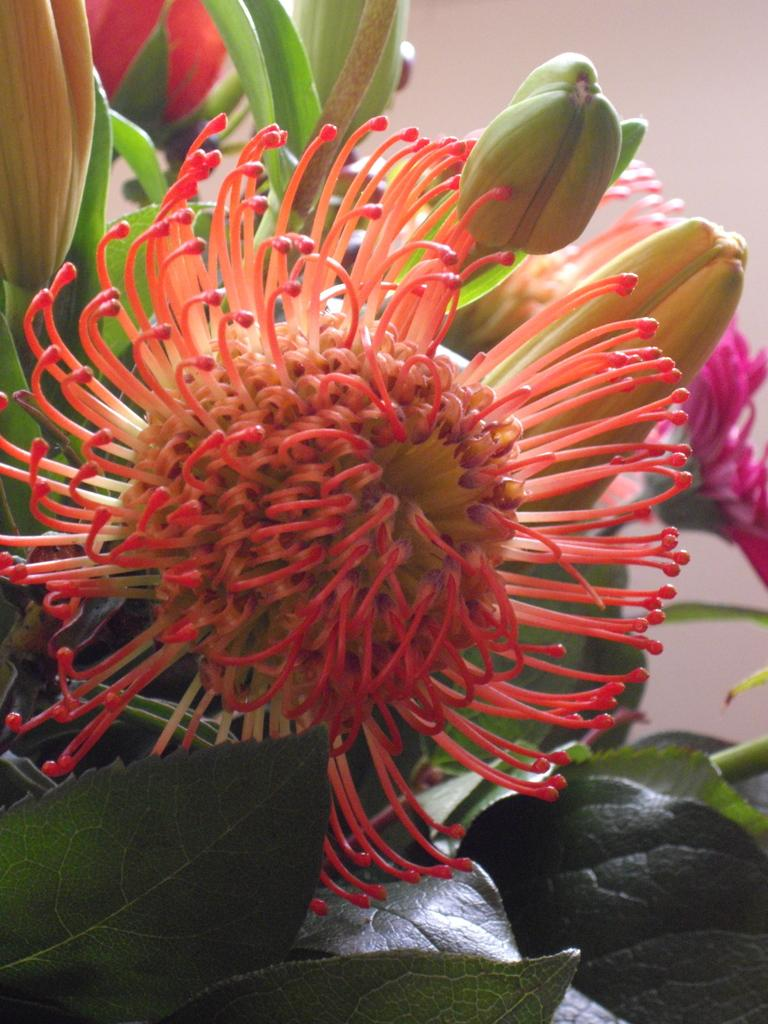What type of living organisms can be seen in the image? There are flowers and plants in the image. Can you describe the plants in the image? The plants in the image are not specified, but they are present alongside the flowers. What advice does the brother give about managing wealth in the image? There is no mention of a brother or wealth in the image; it only features flowers and plants. 